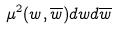Convert formula to latex. <formula><loc_0><loc_0><loc_500><loc_500>\mu ^ { 2 } ( w , \overline { w } ) d w d \overline { w }</formula> 